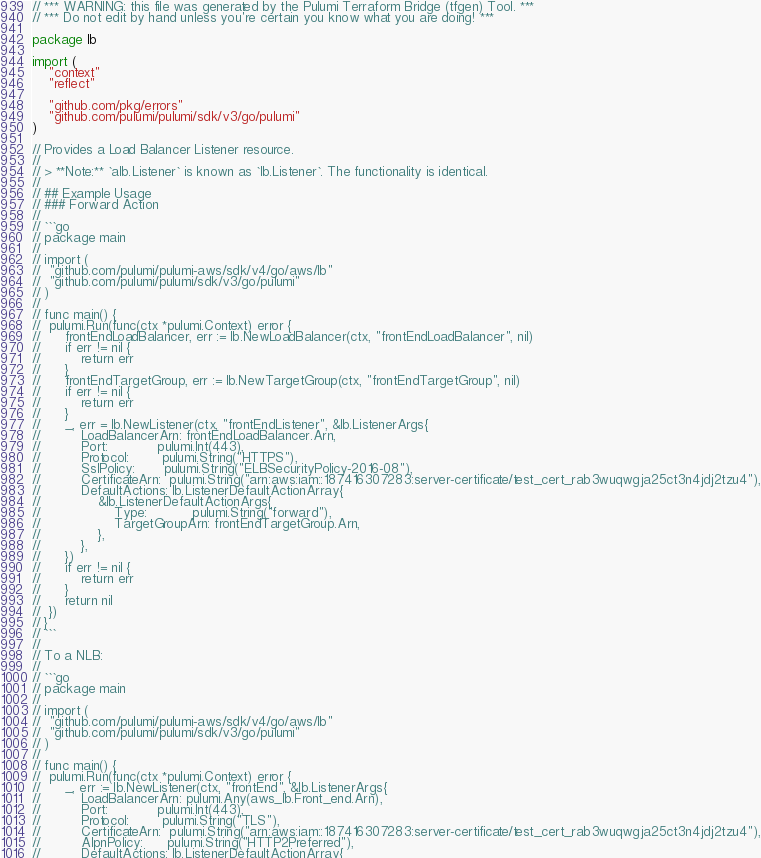Convert code to text. <code><loc_0><loc_0><loc_500><loc_500><_Go_>// *** WARNING: this file was generated by the Pulumi Terraform Bridge (tfgen) Tool. ***
// *** Do not edit by hand unless you're certain you know what you are doing! ***

package lb

import (
	"context"
	"reflect"

	"github.com/pkg/errors"
	"github.com/pulumi/pulumi/sdk/v3/go/pulumi"
)

// Provides a Load Balancer Listener resource.
//
// > **Note:** `alb.Listener` is known as `lb.Listener`. The functionality is identical.
//
// ## Example Usage
// ### Forward Action
//
// ```go
// package main
//
// import (
// 	"github.com/pulumi/pulumi-aws/sdk/v4/go/aws/lb"
// 	"github.com/pulumi/pulumi/sdk/v3/go/pulumi"
// )
//
// func main() {
// 	pulumi.Run(func(ctx *pulumi.Context) error {
// 		frontEndLoadBalancer, err := lb.NewLoadBalancer(ctx, "frontEndLoadBalancer", nil)
// 		if err != nil {
// 			return err
// 		}
// 		frontEndTargetGroup, err := lb.NewTargetGroup(ctx, "frontEndTargetGroup", nil)
// 		if err != nil {
// 			return err
// 		}
// 		_, err = lb.NewListener(ctx, "frontEndListener", &lb.ListenerArgs{
// 			LoadBalancerArn: frontEndLoadBalancer.Arn,
// 			Port:            pulumi.Int(443),
// 			Protocol:        pulumi.String("HTTPS"),
// 			SslPolicy:       pulumi.String("ELBSecurityPolicy-2016-08"),
// 			CertificateArn:  pulumi.String("arn:aws:iam::187416307283:server-certificate/test_cert_rab3wuqwgja25ct3n4jdj2tzu4"),
// 			DefaultActions: lb.ListenerDefaultActionArray{
// 				&lb.ListenerDefaultActionArgs{
// 					Type:           pulumi.String("forward"),
// 					TargetGroupArn: frontEndTargetGroup.Arn,
// 				},
// 			},
// 		})
// 		if err != nil {
// 			return err
// 		}
// 		return nil
// 	})
// }
// ```
//
// To a NLB:
//
// ```go
// package main
//
// import (
// 	"github.com/pulumi/pulumi-aws/sdk/v4/go/aws/lb"
// 	"github.com/pulumi/pulumi/sdk/v3/go/pulumi"
// )
//
// func main() {
// 	pulumi.Run(func(ctx *pulumi.Context) error {
// 		_, err := lb.NewListener(ctx, "frontEnd", &lb.ListenerArgs{
// 			LoadBalancerArn: pulumi.Any(aws_lb.Front_end.Arn),
// 			Port:            pulumi.Int(443),
// 			Protocol:        pulumi.String("TLS"),
// 			CertificateArn:  pulumi.String("arn:aws:iam::187416307283:server-certificate/test_cert_rab3wuqwgja25ct3n4jdj2tzu4"),
// 			AlpnPolicy:      pulumi.String("HTTP2Preferred"),
// 			DefaultActions: lb.ListenerDefaultActionArray{</code> 